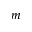Convert formula to latex. <formula><loc_0><loc_0><loc_500><loc_500>m</formula> 